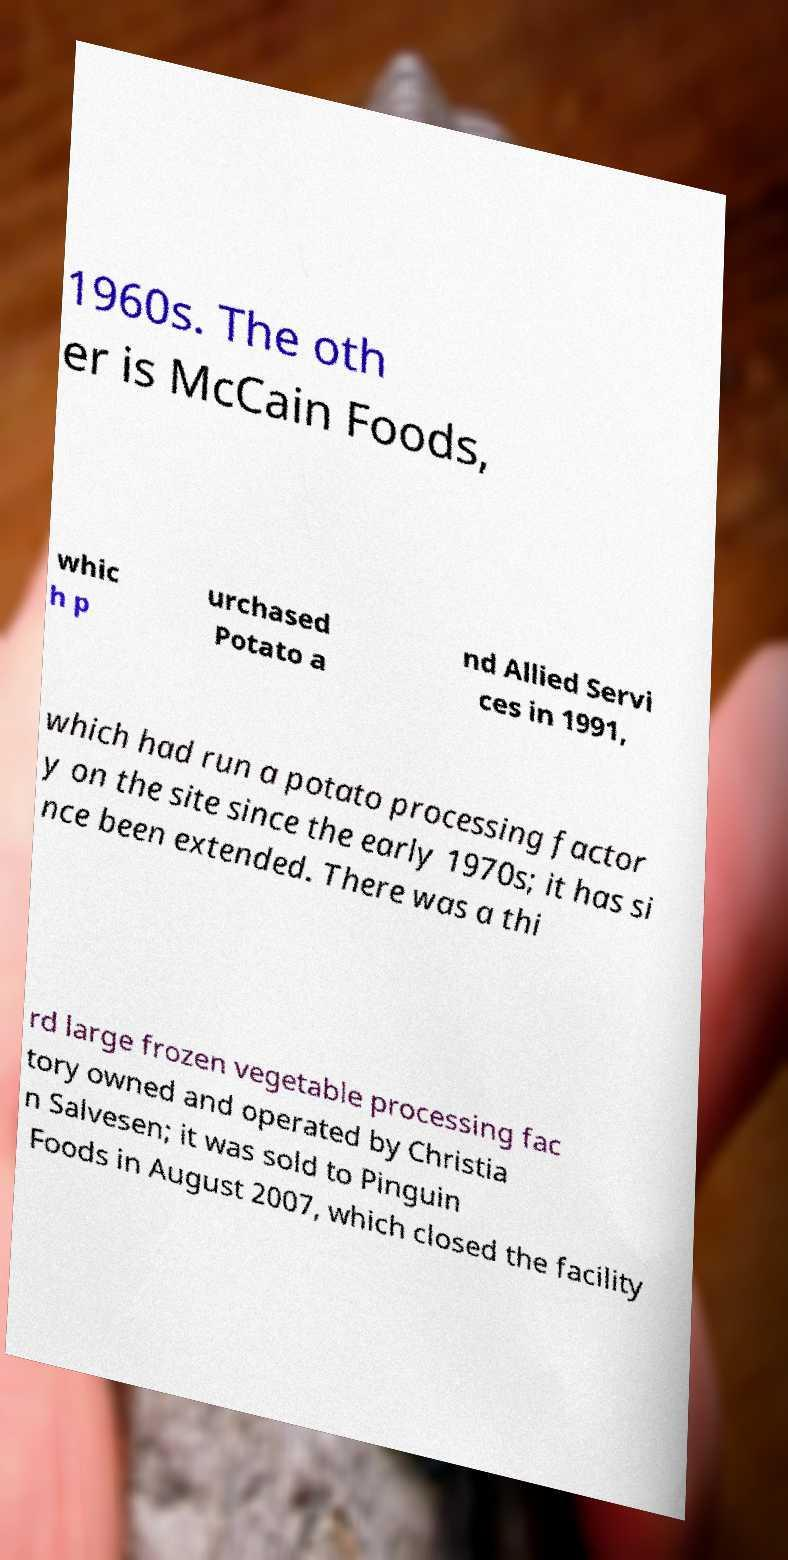Could you extract and type out the text from this image? 1960s. The oth er is McCain Foods, whic h p urchased Potato a nd Allied Servi ces in 1991, which had run a potato processing factor y on the site since the early 1970s; it has si nce been extended. There was a thi rd large frozen vegetable processing fac tory owned and operated by Christia n Salvesen; it was sold to Pinguin Foods in August 2007, which closed the facility 